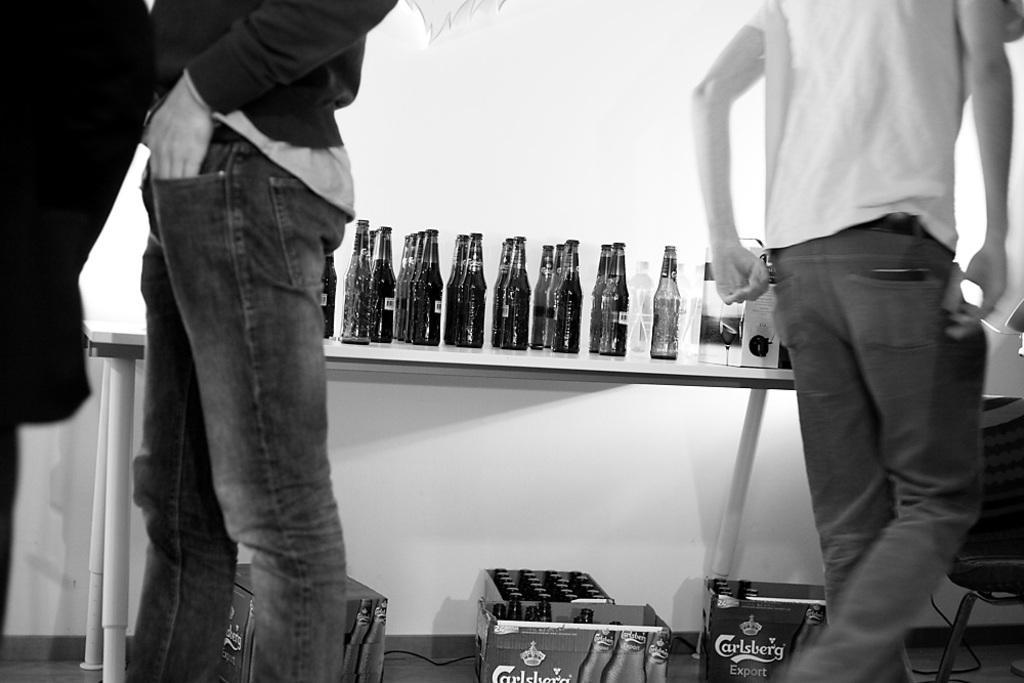In one or two sentences, can you explain what this image depicts? It is the black and white image in which there is a table in the middle. On the table there are glass bottles. On the left side there is a man who is standing on the floor. On the right side there is a man who is walking on the floor. At the bottom there are cardboard boxes in which there are glass bottles. 